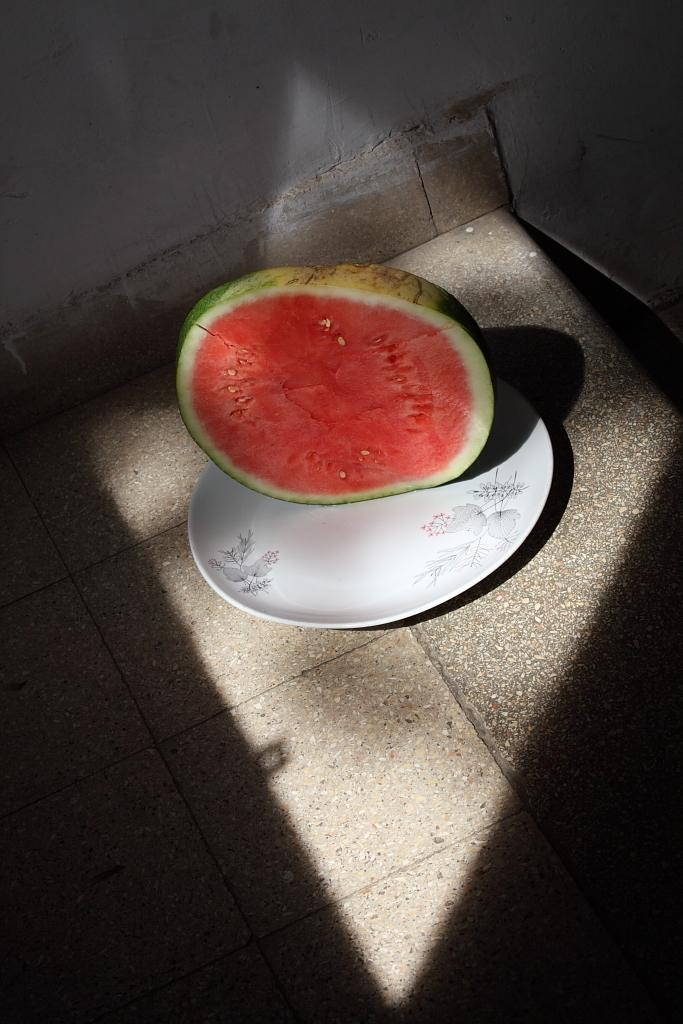What is on the platter in the foreground of the image? There is a cut fruit on a platter in the foreground of the image. Where is the platter placed? The platter is placed on a surface. What can be seen at the top of the image? There is a wall visible at the top of the image. Is there a trick performed by the fruit on the platter in the image? There is no trick being performed by the fruit on the platter in the image. Can you see an island in the background of the image? There is no island visible in the image; only a wall can be seen at the top. 